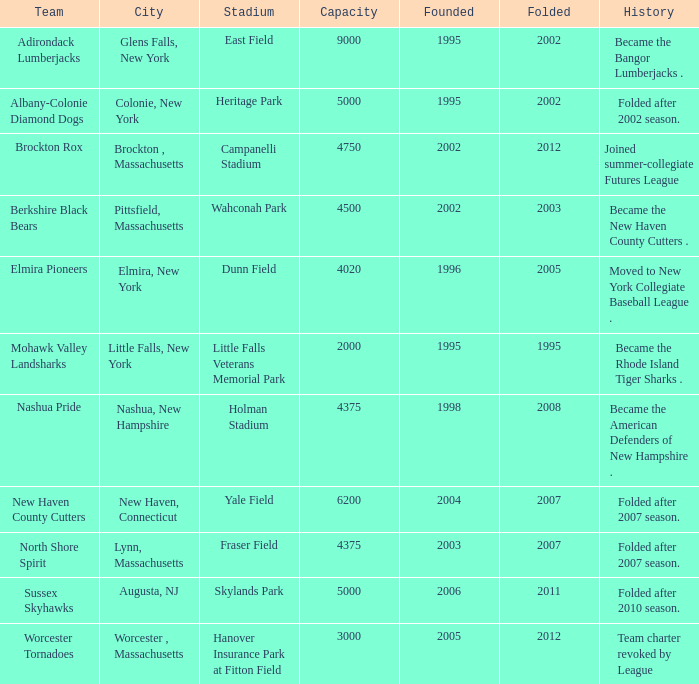What is the maximum founded year of the Worcester Tornadoes? 2005.0. 